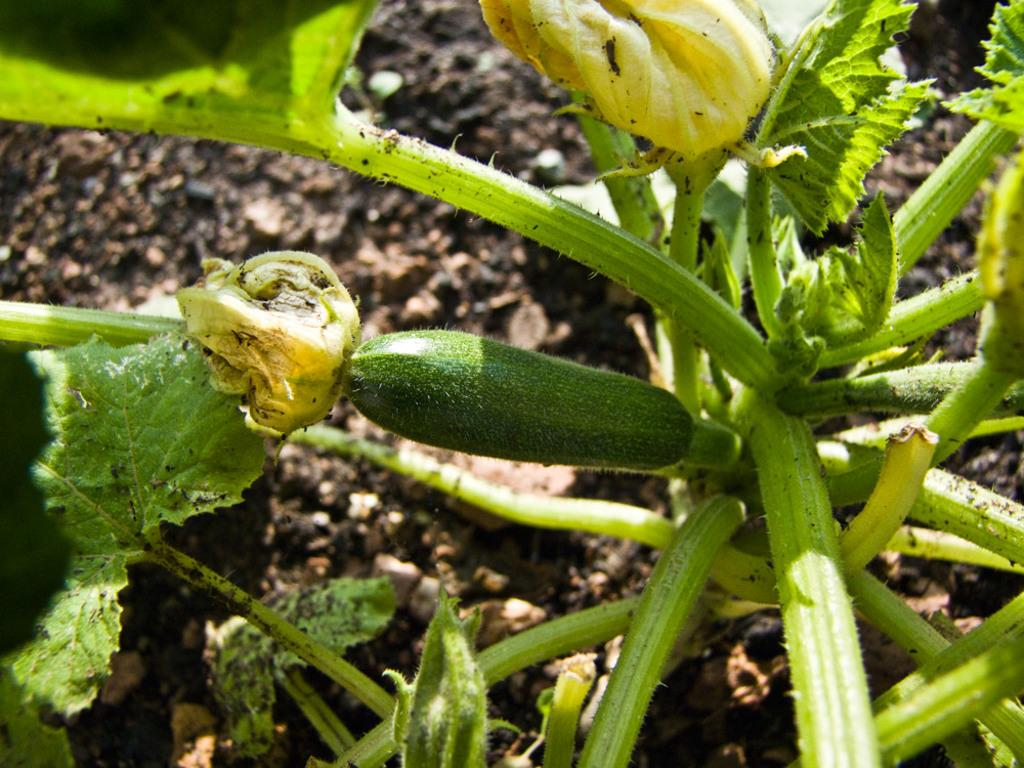What type of living organism can be seen in the image? There is a plant in the image. What type of food item can be seen in the image? There is a vegetable in the image. What type of mitten is being used to measure the plant in the image? There is no mitten or measuring activity present in the image. Is there a chair visible in the image? No, there is no chair present in the image. 